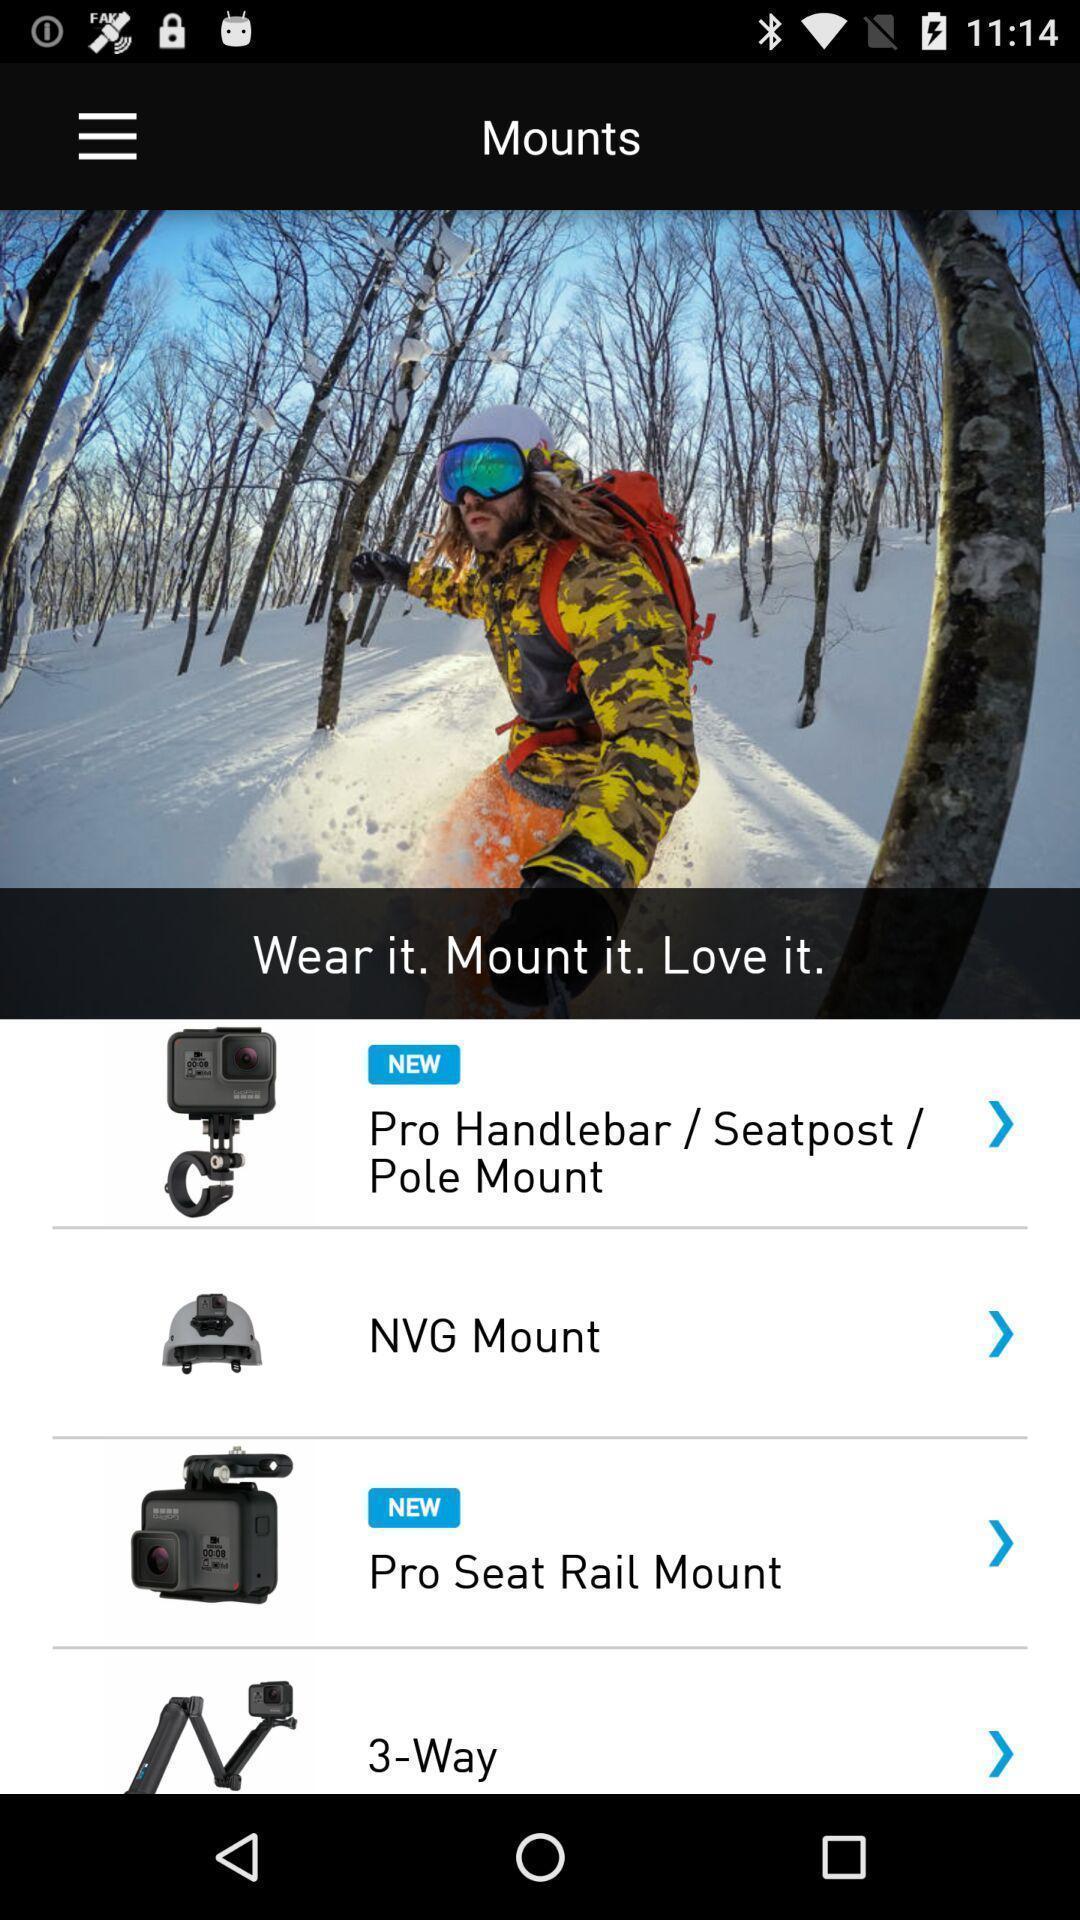Give me a summary of this screen capture. Page showing a list of products. 